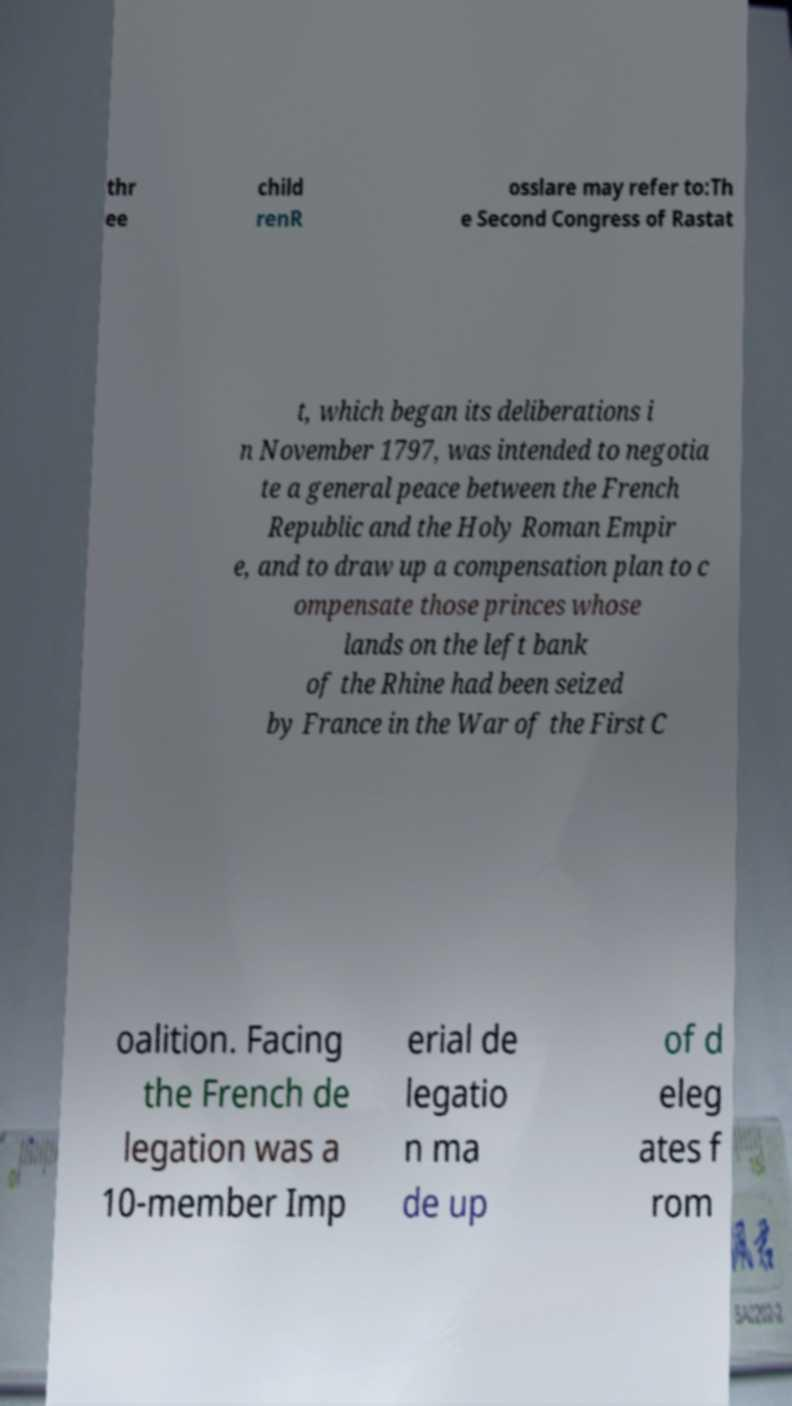I need the written content from this picture converted into text. Can you do that? thr ee child renR osslare may refer to:Th e Second Congress of Rastat t, which began its deliberations i n November 1797, was intended to negotia te a general peace between the French Republic and the Holy Roman Empir e, and to draw up a compensation plan to c ompensate those princes whose lands on the left bank of the Rhine had been seized by France in the War of the First C oalition. Facing the French de legation was a 10-member Imp erial de legatio n ma de up of d eleg ates f rom 